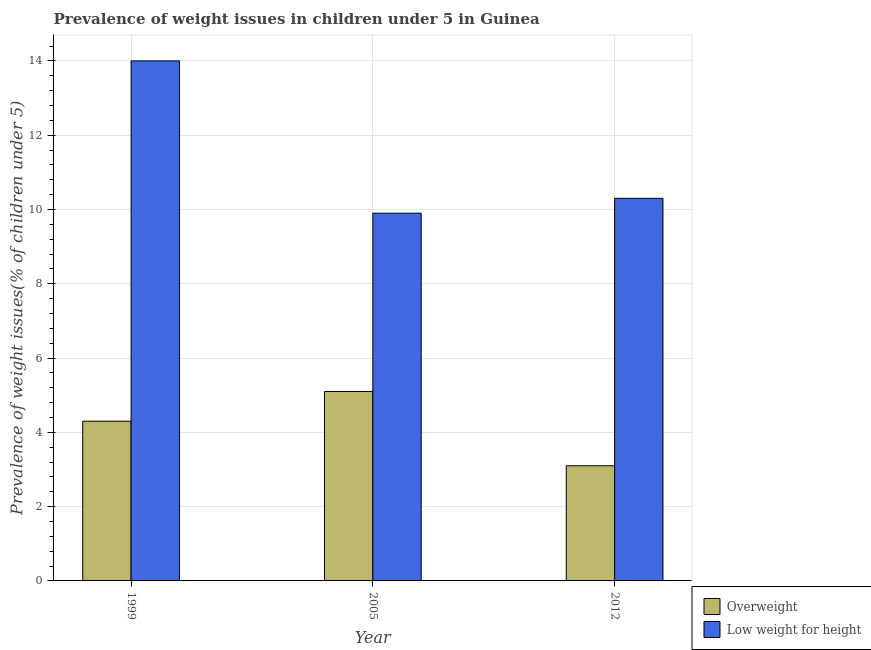How many different coloured bars are there?
Your response must be concise. 2. How many bars are there on the 3rd tick from the left?
Provide a succinct answer. 2. How many bars are there on the 1st tick from the right?
Make the answer very short. 2. What is the label of the 2nd group of bars from the left?
Offer a very short reply. 2005. What is the percentage of overweight children in 1999?
Your answer should be very brief. 4.3. Across all years, what is the maximum percentage of overweight children?
Give a very brief answer. 5.1. Across all years, what is the minimum percentage of underweight children?
Your answer should be compact. 9.9. What is the total percentage of overweight children in the graph?
Provide a succinct answer. 12.5. What is the difference between the percentage of overweight children in 1999 and that in 2012?
Your answer should be compact. 1.2. What is the difference between the percentage of underweight children in 2005 and the percentage of overweight children in 2012?
Your answer should be very brief. -0.4. What is the average percentage of underweight children per year?
Offer a terse response. 11.4. What is the ratio of the percentage of overweight children in 2005 to that in 2012?
Offer a very short reply. 1.65. Is the difference between the percentage of underweight children in 1999 and 2005 greater than the difference between the percentage of overweight children in 1999 and 2005?
Your answer should be very brief. No. What is the difference between the highest and the second highest percentage of underweight children?
Provide a succinct answer. 3.7. What is the difference between the highest and the lowest percentage of underweight children?
Keep it short and to the point. 4.1. In how many years, is the percentage of overweight children greater than the average percentage of overweight children taken over all years?
Provide a short and direct response. 2. Is the sum of the percentage of overweight children in 1999 and 2012 greater than the maximum percentage of underweight children across all years?
Your answer should be very brief. Yes. What does the 2nd bar from the left in 1999 represents?
Offer a very short reply. Low weight for height. What does the 1st bar from the right in 1999 represents?
Offer a very short reply. Low weight for height. Are all the bars in the graph horizontal?
Keep it short and to the point. No. How many years are there in the graph?
Ensure brevity in your answer.  3. What is the difference between two consecutive major ticks on the Y-axis?
Your answer should be compact. 2. Are the values on the major ticks of Y-axis written in scientific E-notation?
Offer a very short reply. No. Where does the legend appear in the graph?
Ensure brevity in your answer.  Bottom right. How many legend labels are there?
Provide a succinct answer. 2. How are the legend labels stacked?
Offer a very short reply. Vertical. What is the title of the graph?
Provide a short and direct response. Prevalence of weight issues in children under 5 in Guinea. What is the label or title of the Y-axis?
Make the answer very short. Prevalence of weight issues(% of children under 5). What is the Prevalence of weight issues(% of children under 5) of Overweight in 1999?
Ensure brevity in your answer.  4.3. What is the Prevalence of weight issues(% of children under 5) of Low weight for height in 1999?
Provide a short and direct response. 14. What is the Prevalence of weight issues(% of children under 5) in Overweight in 2005?
Your answer should be very brief. 5.1. What is the Prevalence of weight issues(% of children under 5) in Low weight for height in 2005?
Make the answer very short. 9.9. What is the Prevalence of weight issues(% of children under 5) of Overweight in 2012?
Offer a terse response. 3.1. What is the Prevalence of weight issues(% of children under 5) of Low weight for height in 2012?
Offer a very short reply. 10.3. Across all years, what is the maximum Prevalence of weight issues(% of children under 5) of Overweight?
Offer a very short reply. 5.1. Across all years, what is the minimum Prevalence of weight issues(% of children under 5) of Overweight?
Your answer should be compact. 3.1. Across all years, what is the minimum Prevalence of weight issues(% of children under 5) in Low weight for height?
Your response must be concise. 9.9. What is the total Prevalence of weight issues(% of children under 5) of Overweight in the graph?
Make the answer very short. 12.5. What is the total Prevalence of weight issues(% of children under 5) of Low weight for height in the graph?
Ensure brevity in your answer.  34.2. What is the difference between the Prevalence of weight issues(% of children under 5) in Low weight for height in 1999 and that in 2005?
Make the answer very short. 4.1. What is the difference between the Prevalence of weight issues(% of children under 5) of Overweight in 1999 and that in 2012?
Make the answer very short. 1.2. What is the difference between the Prevalence of weight issues(% of children under 5) of Overweight in 1999 and the Prevalence of weight issues(% of children under 5) of Low weight for height in 2012?
Provide a short and direct response. -6. What is the difference between the Prevalence of weight issues(% of children under 5) of Overweight in 2005 and the Prevalence of weight issues(% of children under 5) of Low weight for height in 2012?
Offer a terse response. -5.2. What is the average Prevalence of weight issues(% of children under 5) of Overweight per year?
Provide a short and direct response. 4.17. What is the ratio of the Prevalence of weight issues(% of children under 5) in Overweight in 1999 to that in 2005?
Offer a very short reply. 0.84. What is the ratio of the Prevalence of weight issues(% of children under 5) of Low weight for height in 1999 to that in 2005?
Your response must be concise. 1.41. What is the ratio of the Prevalence of weight issues(% of children under 5) of Overweight in 1999 to that in 2012?
Your answer should be very brief. 1.39. What is the ratio of the Prevalence of weight issues(% of children under 5) of Low weight for height in 1999 to that in 2012?
Your response must be concise. 1.36. What is the ratio of the Prevalence of weight issues(% of children under 5) of Overweight in 2005 to that in 2012?
Make the answer very short. 1.65. What is the ratio of the Prevalence of weight issues(% of children under 5) in Low weight for height in 2005 to that in 2012?
Ensure brevity in your answer.  0.96. What is the difference between the highest and the lowest Prevalence of weight issues(% of children under 5) in Overweight?
Provide a succinct answer. 2. What is the difference between the highest and the lowest Prevalence of weight issues(% of children under 5) in Low weight for height?
Keep it short and to the point. 4.1. 